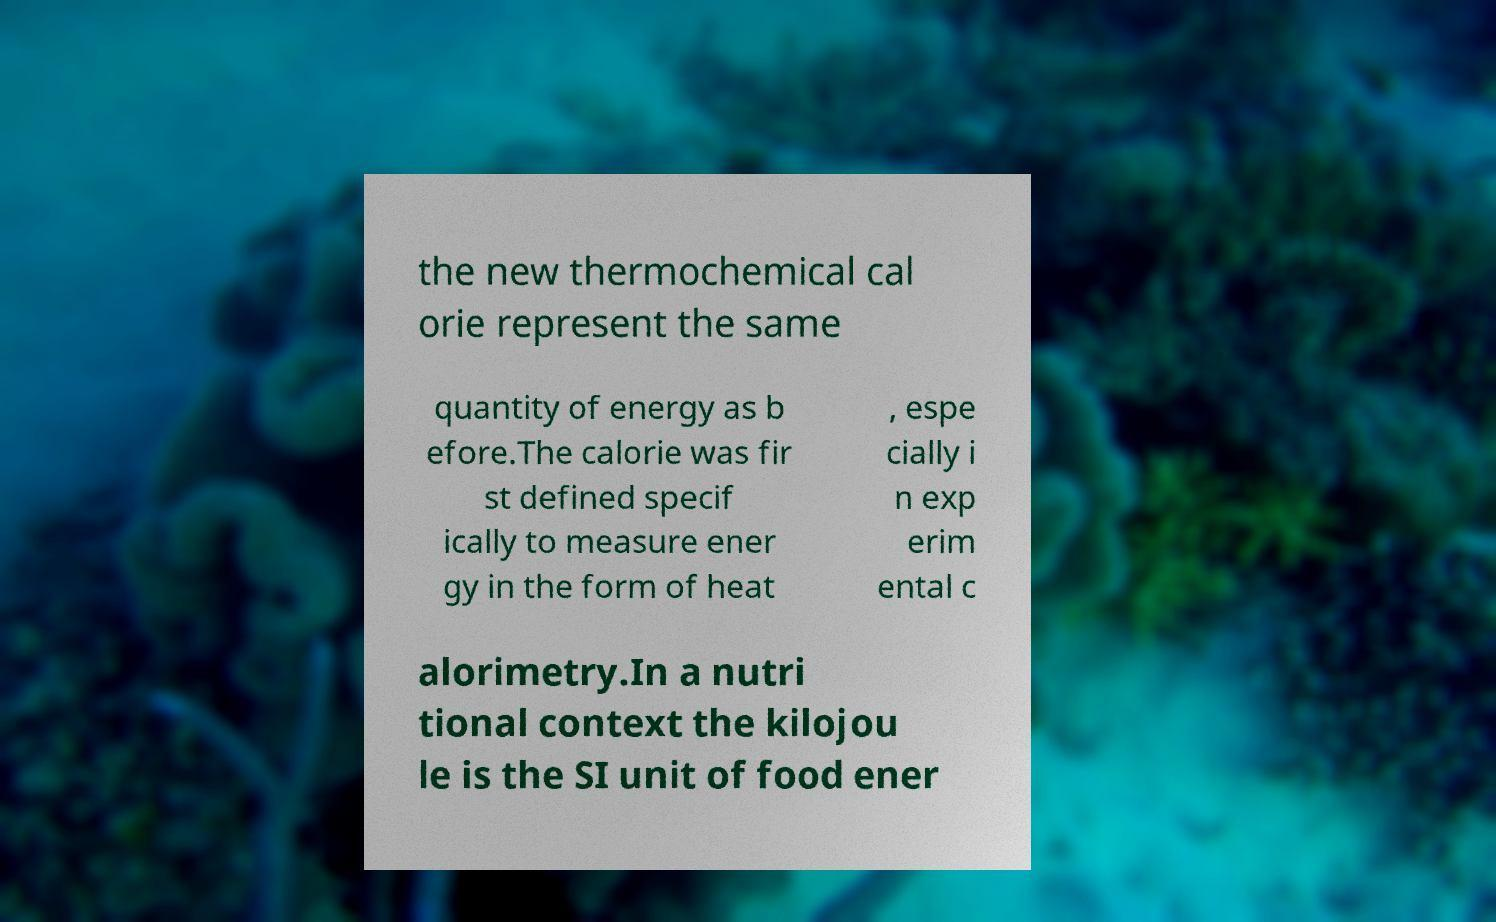Could you assist in decoding the text presented in this image and type it out clearly? the new thermochemical cal orie represent the same quantity of energy as b efore.The calorie was fir st defined specif ically to measure ener gy in the form of heat , espe cially i n exp erim ental c alorimetry.In a nutri tional context the kilojou le is the SI unit of food ener 